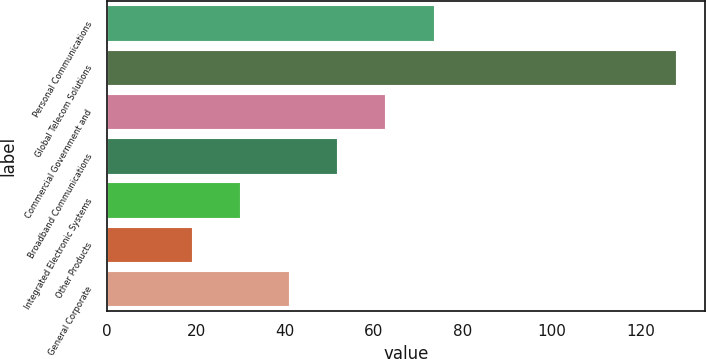Convert chart. <chart><loc_0><loc_0><loc_500><loc_500><bar_chart><fcel>Personal Communications<fcel>Global Telecom Solutions<fcel>Commercial Government and<fcel>Broadband Communications<fcel>Integrated Electronic Systems<fcel>Other Products<fcel>General Corporate<nl><fcel>73.5<fcel>128<fcel>62.6<fcel>51.7<fcel>29.9<fcel>19<fcel>40.8<nl></chart> 